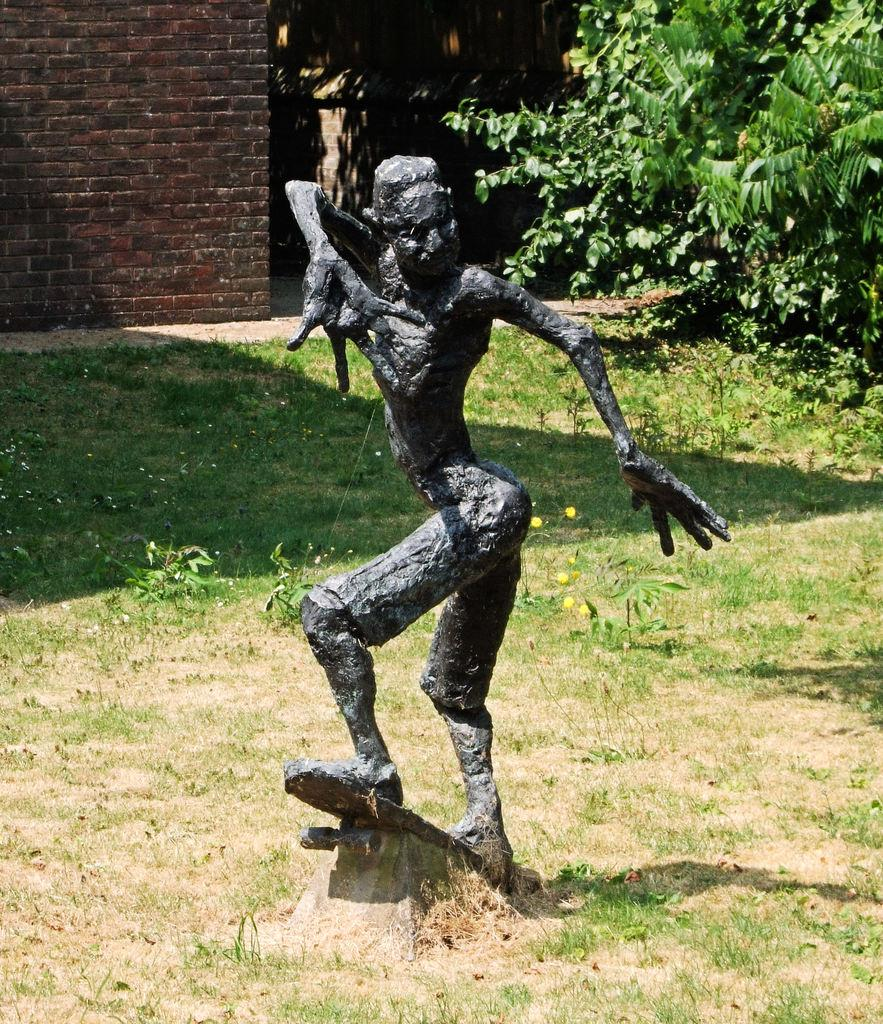What is the main subject in the image? There is a statue in the image. How is the statue positioned in the image? The statue is on a skateboard. What can be seen in the background of the image? There is a wall, plants, grass, and trees in the background of the image. What type of coil is being used to support the statue's belief in the image? There is no coil or reference to belief present in the image; it features a statue on a skateboard with a background of a wall, plants, grass, and trees. 